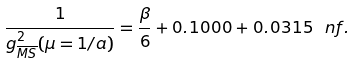Convert formula to latex. <formula><loc_0><loc_0><loc_500><loc_500>\frac { 1 } { g ^ { 2 } _ { \overline { M S } } ( \mu = 1 / a ) } = \frac { \beta } { 6 } + 0 . 1 0 0 0 + 0 . 0 3 1 5 \ n f .</formula> 